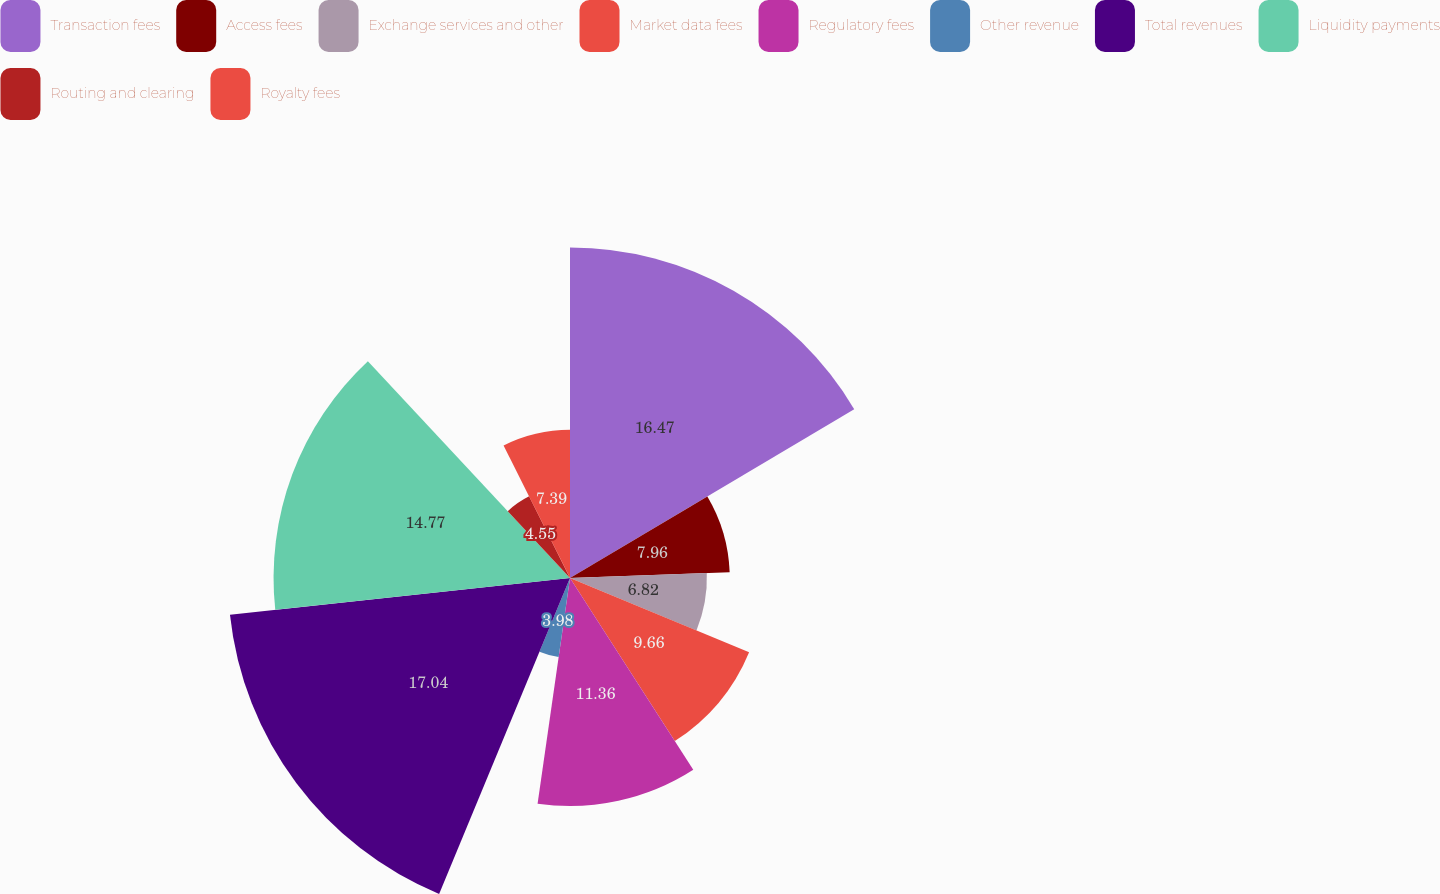Convert chart. <chart><loc_0><loc_0><loc_500><loc_500><pie_chart><fcel>Transaction fees<fcel>Access fees<fcel>Exchange services and other<fcel>Market data fees<fcel>Regulatory fees<fcel>Other revenue<fcel>Total revenues<fcel>Liquidity payments<fcel>Routing and clearing<fcel>Royalty fees<nl><fcel>16.47%<fcel>7.96%<fcel>6.82%<fcel>9.66%<fcel>11.36%<fcel>3.98%<fcel>17.04%<fcel>14.77%<fcel>4.55%<fcel>7.39%<nl></chart> 